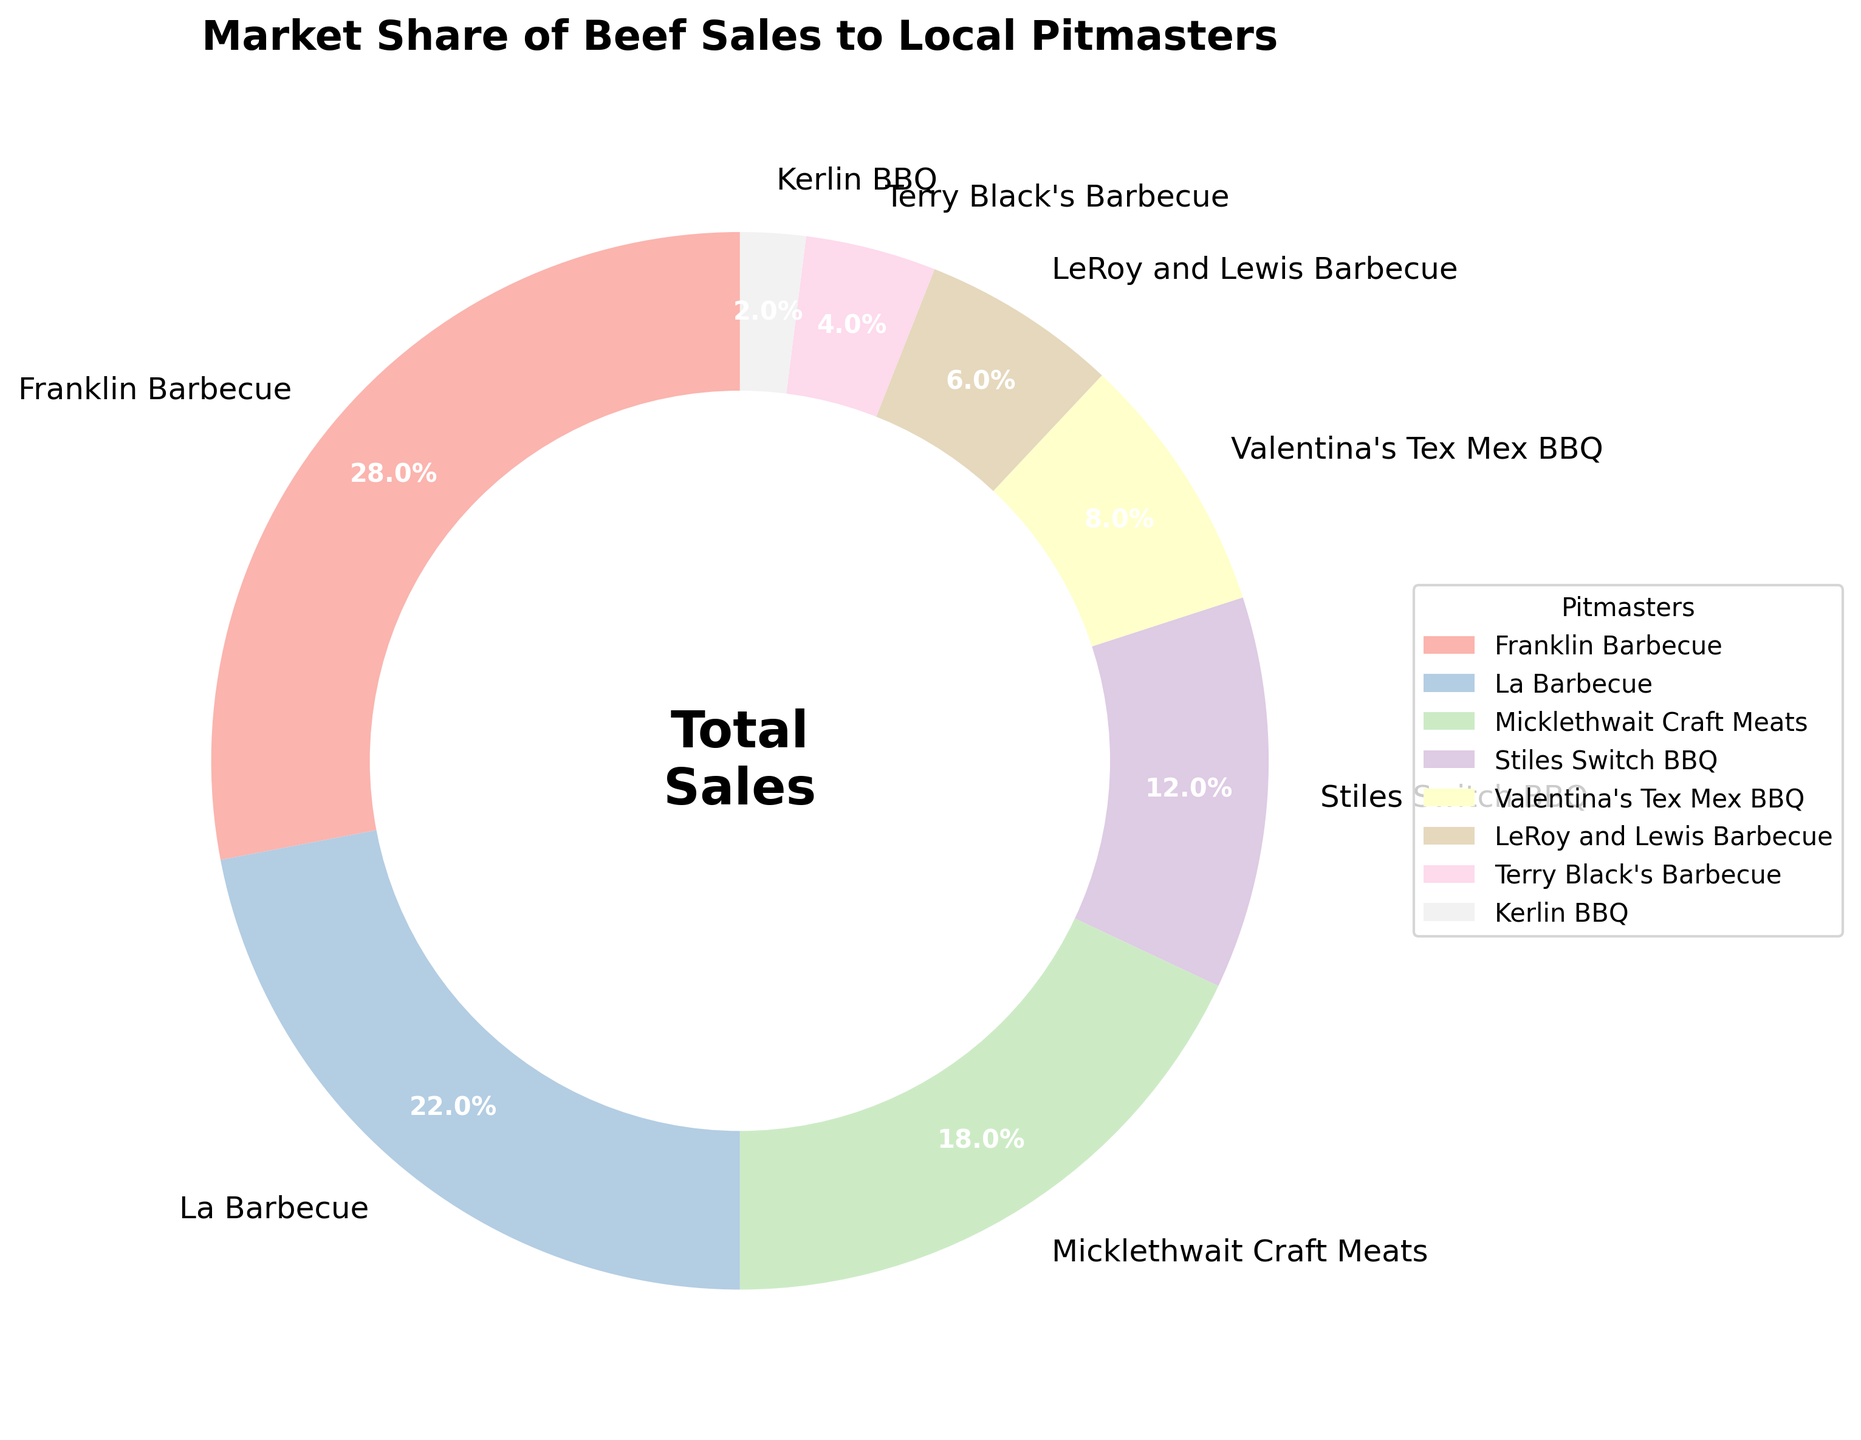Which pitmaster has the largest market share? The slices of the pie chart are labeled with percentages, and the largest percentage corresponds to Franklin Barbecue with 28%.
Answer: Franklin Barbecue Which two pitmasters have the smallest market shares combined? The smallest slices on the pie chart are Kerlin BBQ with 2% and Terry Black's Barbecue with 4%. Combined, they constitute 2% + 4% = 6%.
Answer: Kerlin BBQ and Terry Black's Barbecue How much larger is La Barbecue's market share compared to Stiles Switch BBQ? La Barbecue has 22% and Stiles Switch BBQ has 12%. The difference is 22% - 12% = 10%.
Answer: 10% What is the combined market share of the three largest pitmasters? The three largest market shares belong to Franklin Barbecue (28%), La Barbecue (22%), and Micklethwait Craft Meats (18%). Combined, their market share is 28% + 22% + 18% = 68%.
Answer: 68% How does Valentina's Tex Mex BBQ's market share compare to LeRoy and Lewis Barbecue? Valentina's Tex Mex BBQ has a market share of 8% and LeRoy and Lewis Barbecue has 6%. Valentina's Tex Mex BBQ's market share is 8% - 6% larger by 2%.
Answer: Valentina's Tex Mex BBQ What percentage of the market is not held by the top three pitmasters? The top three pitmasters hold a combined market share of 68%. The market not held by them is 100% - 68% = 32%.
Answer: 32% Which pitmaster's market share is closest in size to Valentina's Tex Mex BBQ's market share? By looking at the percentages, Stiles Switch BBQ has a market share of 12%, which is closest to Valentina's Tex Mex BBQ's 8%.
Answer: Stiles Switch BBQ What is the total market share of those pitmasters who have less than 10% each? The pitmasters with less than 10% each are Valentina's Tex Mex BBQ (8%), LeRoy and Lewis Barbecue (6%), Terry Black's Barbecue (4%), and Kerlin BBQ (2%). Summing these gives 8% + 6% + 4% + 2% = 20%.
Answer: 20% Which pitmasters combined have a market share greater than 50%? The pitmasters and their market shares are Franklin Barbecue (28%), La Barbecue (22%), Micklethwait Craft Meats (18%), and Stiles Switch BBQ (12%). Summing from the largest, Franklin Barbecue and La Barbecue already exceed 50%: 28% + 22% = 50%. Thus, Franklin Barbecue and La Barbecue alone have a combined market share greater than 50%.
Answer: Franklin Barbecue and La Barbecue Is the market share of LeRoy and Lewis Barbecue more or less than half of the market share of Micklethwait Craft Meats? Micklethwait Craft Meats has an 18% market share, and half of that is 9%. LeRoy and Lewis Barbecue has a 6% market share, which is less than 9%.
Answer: Less 